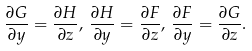Convert formula to latex. <formula><loc_0><loc_0><loc_500><loc_500>\frac { \partial G } { \partial y } = \frac { \partial H } { \partial z } , \, \frac { \partial H } { \partial y } = \frac { \partial F } { \partial z } , \, \frac { \partial F } { \partial y } = \frac { \partial G } { \partial z } .</formula> 